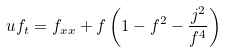<formula> <loc_0><loc_0><loc_500><loc_500>u f _ { t } = f _ { x x } + f \left ( 1 - f ^ { 2 } - \frac { j ^ { 2 } } { f ^ { 4 } } \right )</formula> 